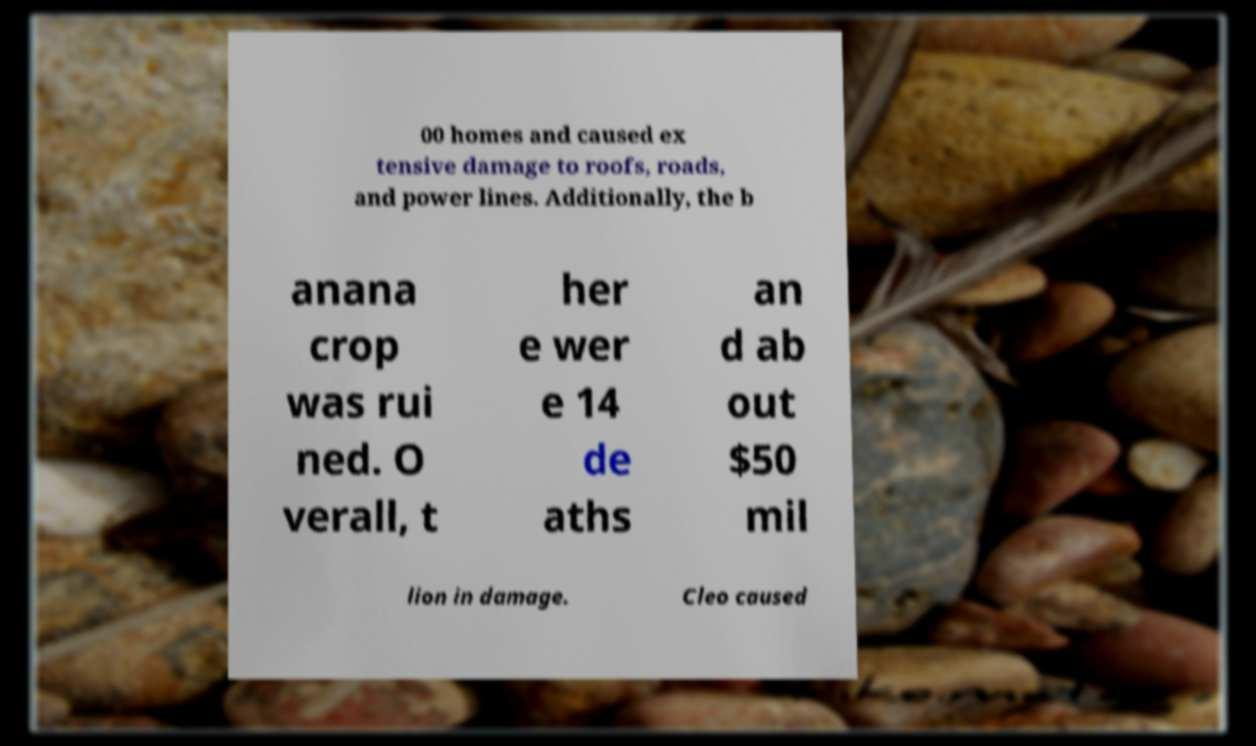What messages or text are displayed in this image? I need them in a readable, typed format. 00 homes and caused ex tensive damage to roofs, roads, and power lines. Additionally, the b anana crop was rui ned. O verall, t her e wer e 14 de aths an d ab out $50 mil lion in damage. Cleo caused 